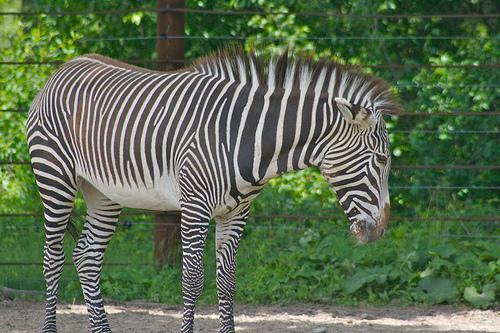How many zebras are there?
Give a very brief answer. 1. 